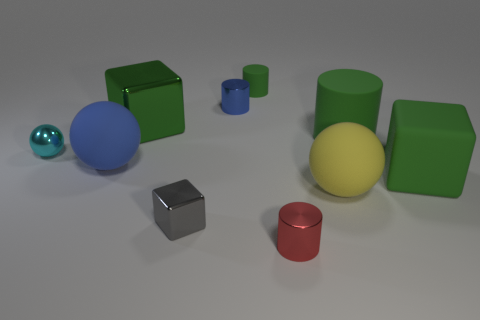Subtract all cylinders. How many objects are left? 6 Subtract 0 gray cylinders. How many objects are left? 10 Subtract all tiny red shiny cubes. Subtract all small cyan things. How many objects are left? 9 Add 5 red metal cylinders. How many red metal cylinders are left? 6 Add 4 small cyan shiny spheres. How many small cyan shiny spheres exist? 5 